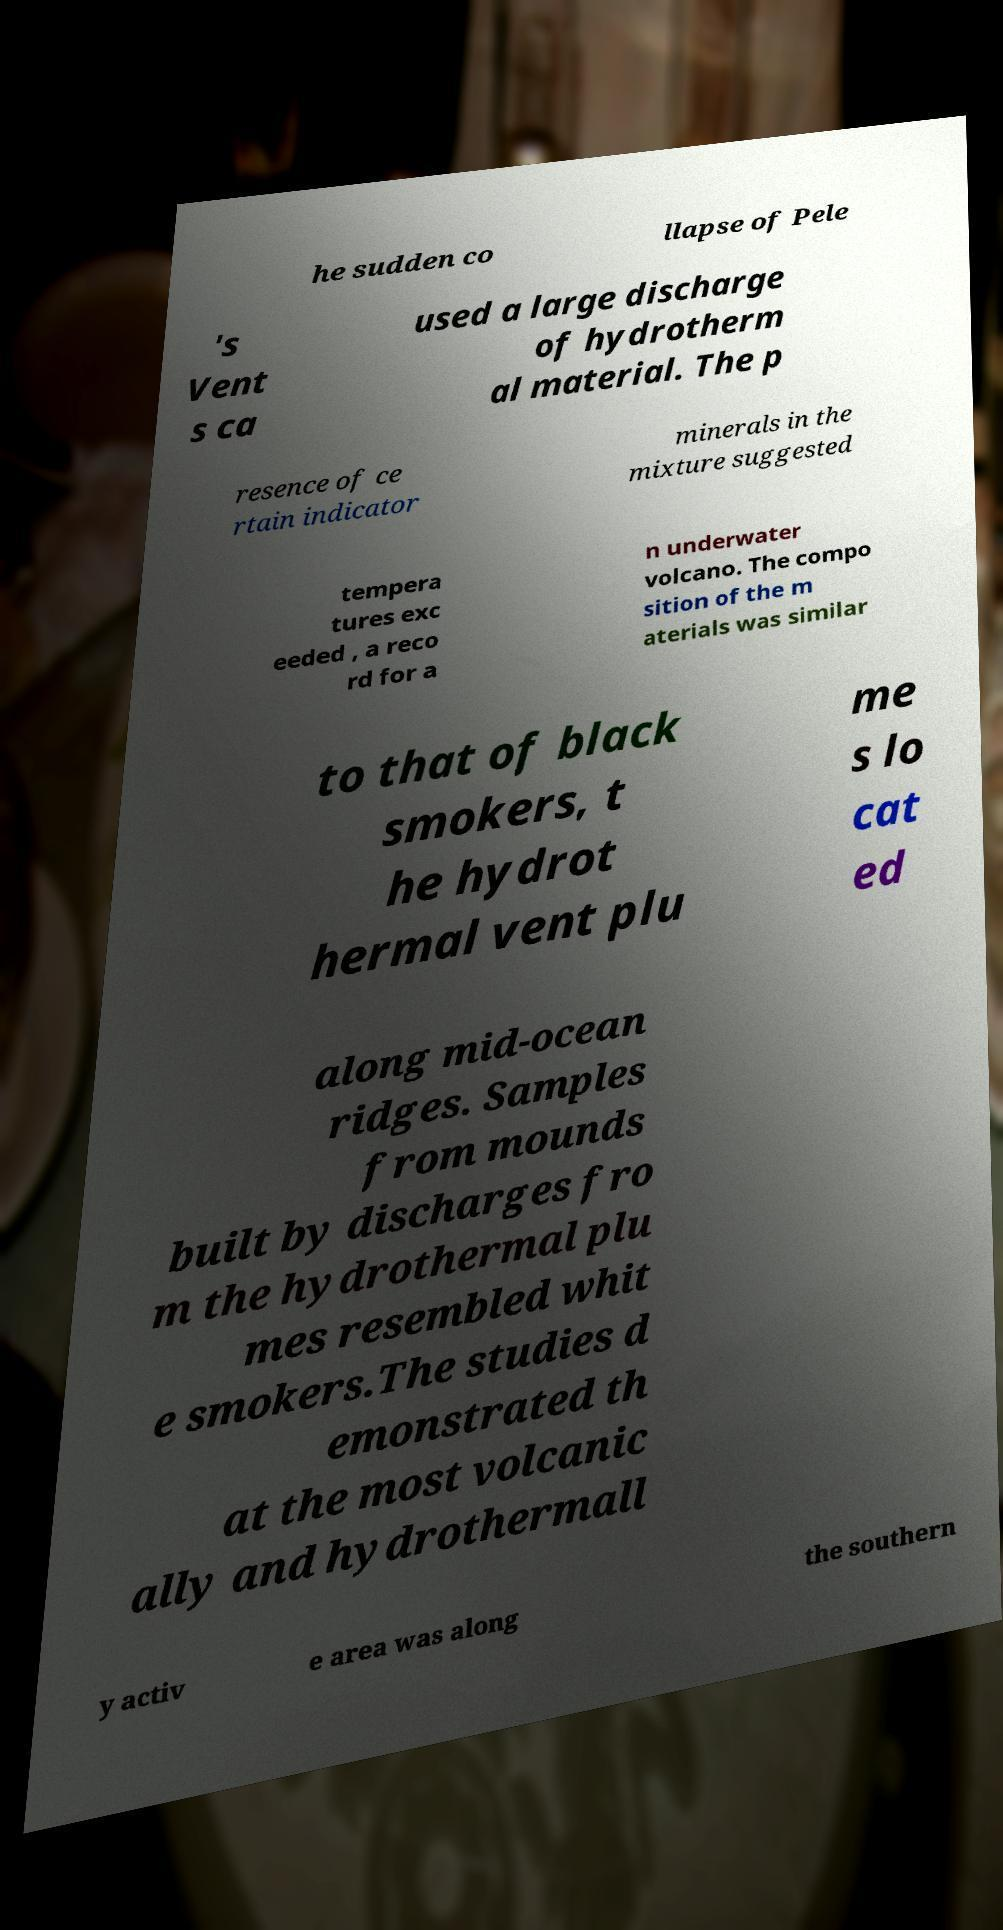Can you accurately transcribe the text from the provided image for me? he sudden co llapse of Pele 's Vent s ca used a large discharge of hydrotherm al material. The p resence of ce rtain indicator minerals in the mixture suggested tempera tures exc eeded , a reco rd for a n underwater volcano. The compo sition of the m aterials was similar to that of black smokers, t he hydrot hermal vent plu me s lo cat ed along mid-ocean ridges. Samples from mounds built by discharges fro m the hydrothermal plu mes resembled whit e smokers.The studies d emonstrated th at the most volcanic ally and hydrothermall y activ e area was along the southern 